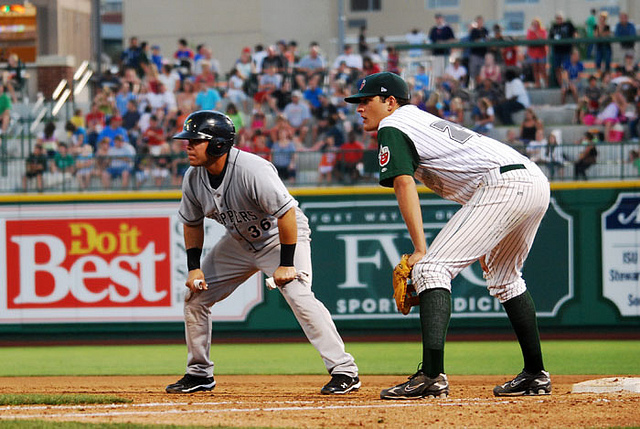Please transcribe the text in this image. Do it Best 36 SPOR DIC 